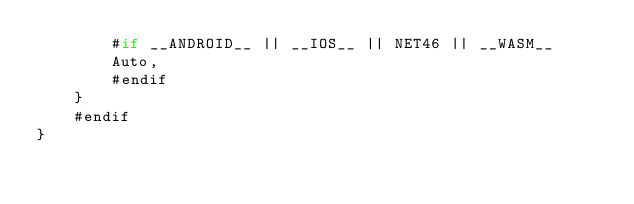Convert code to text. <code><loc_0><loc_0><loc_500><loc_500><_C#_>		#if __ANDROID__ || __IOS__ || NET46 || __WASM__
		Auto,
		#endif
	}
	#endif
}
</code> 